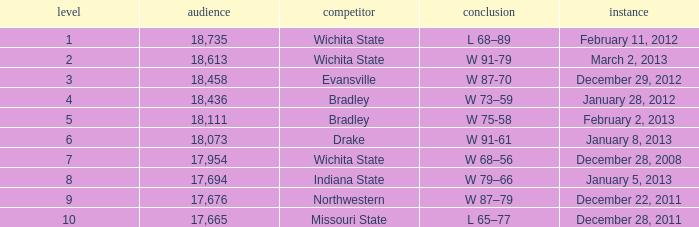What's the rank for February 11, 2012 with less than 18,735 in attendance? None. 